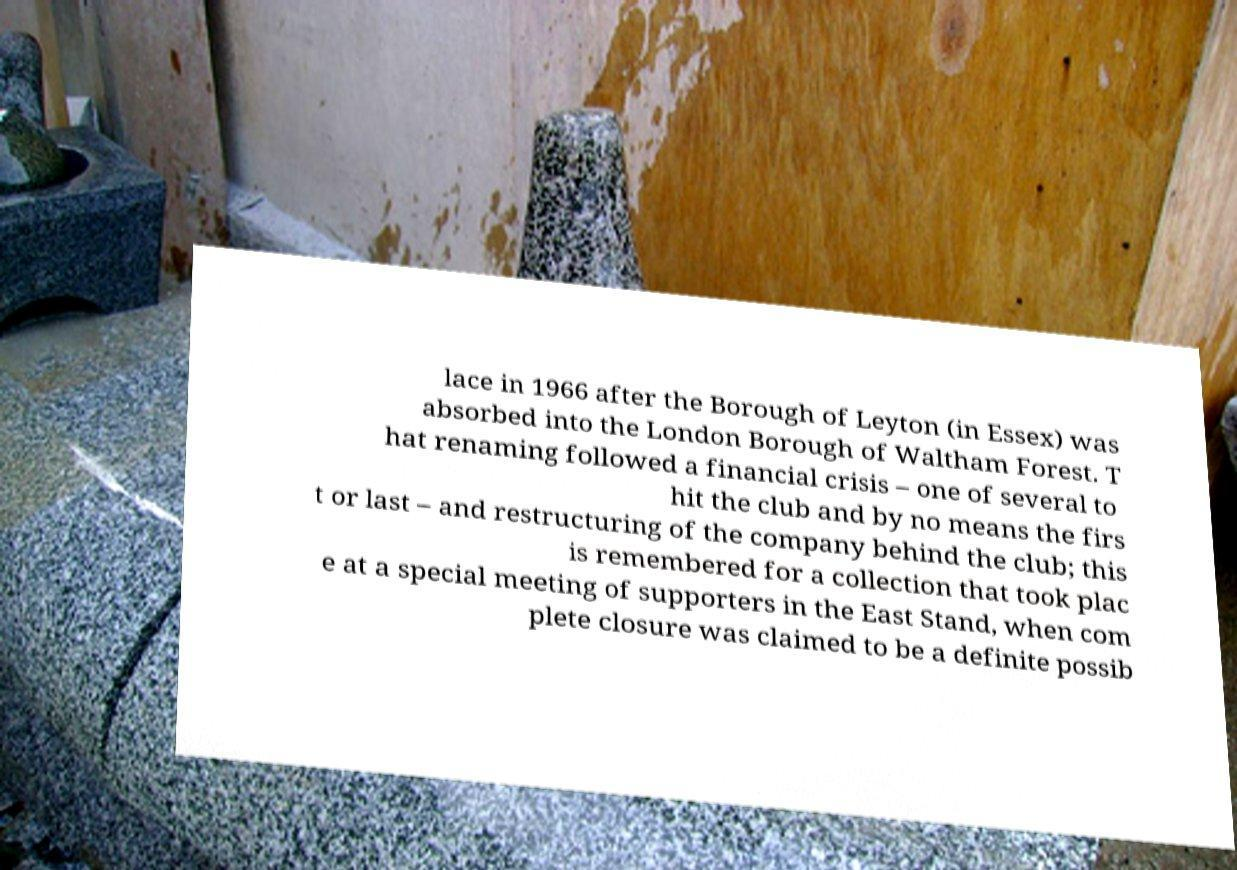Please identify and transcribe the text found in this image. lace in 1966 after the Borough of Leyton (in Essex) was absorbed into the London Borough of Waltham Forest. T hat renaming followed a financial crisis – one of several to hit the club and by no means the firs t or last – and restructuring of the company behind the club; this is remembered for a collection that took plac e at a special meeting of supporters in the East Stand, when com plete closure was claimed to be a definite possib 